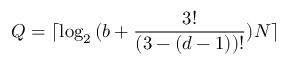Convert formula to latex. <formula><loc_0><loc_0><loc_500><loc_500>Q = \lceil \log _ { 2 } { ( b + \frac { 3 ! } { ( 3 - ( d - 1 ) ) ! } ) N } \rceil</formula> 